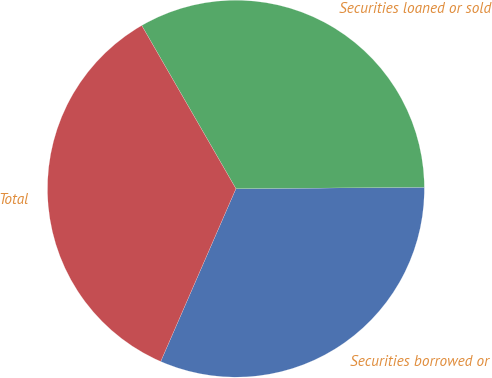Convert chart to OTSL. <chart><loc_0><loc_0><loc_500><loc_500><pie_chart><fcel>Securities borrowed or<fcel>Securities loaned or sold<fcel>Total<nl><fcel>31.65%<fcel>33.21%<fcel>35.13%<nl></chart> 